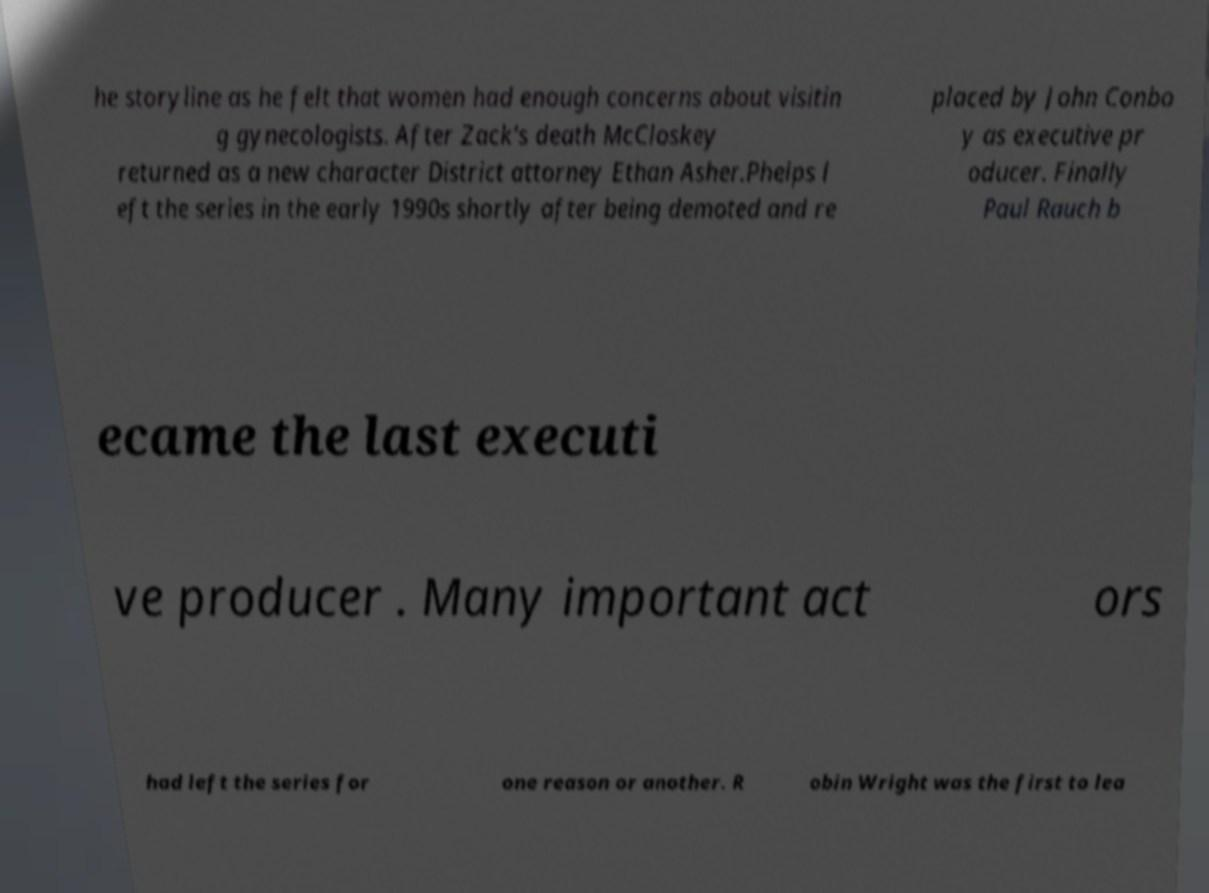Could you assist in decoding the text presented in this image and type it out clearly? he storyline as he felt that women had enough concerns about visitin g gynecologists. After Zack's death McCloskey returned as a new character District attorney Ethan Asher.Phelps l eft the series in the early 1990s shortly after being demoted and re placed by John Conbo y as executive pr oducer. Finally Paul Rauch b ecame the last executi ve producer . Many important act ors had left the series for one reason or another. R obin Wright was the first to lea 